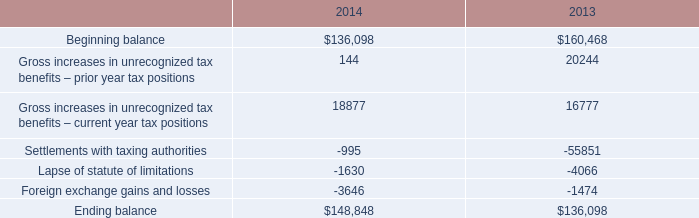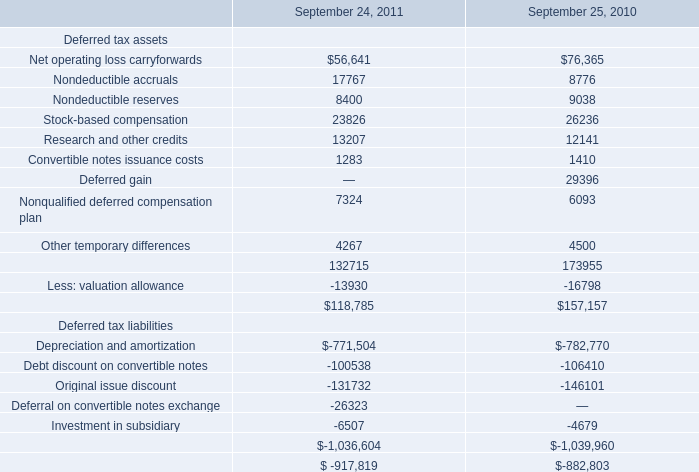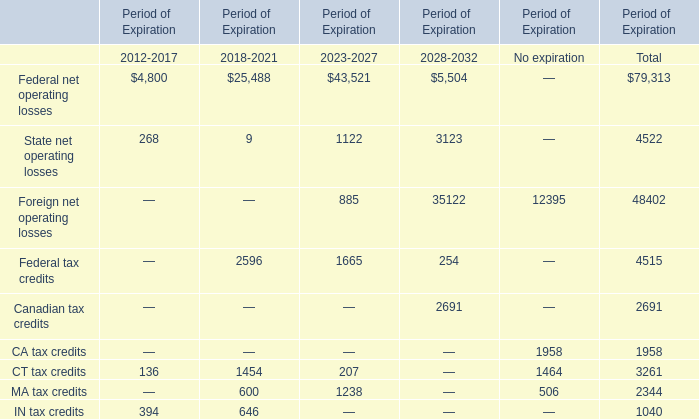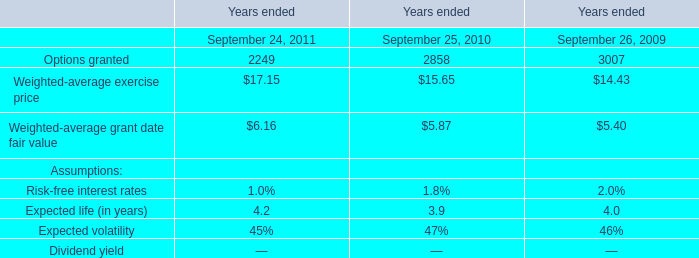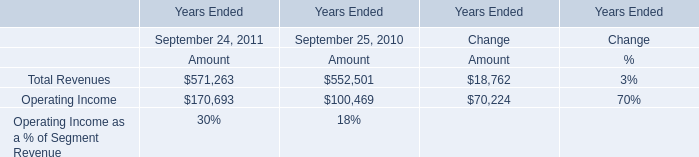What is the sum of the Other temporary differences in the years where Net operating loss carryforwards greater than 0 ? 
Computations: (4267 + 4500)
Answer: 8767.0. 